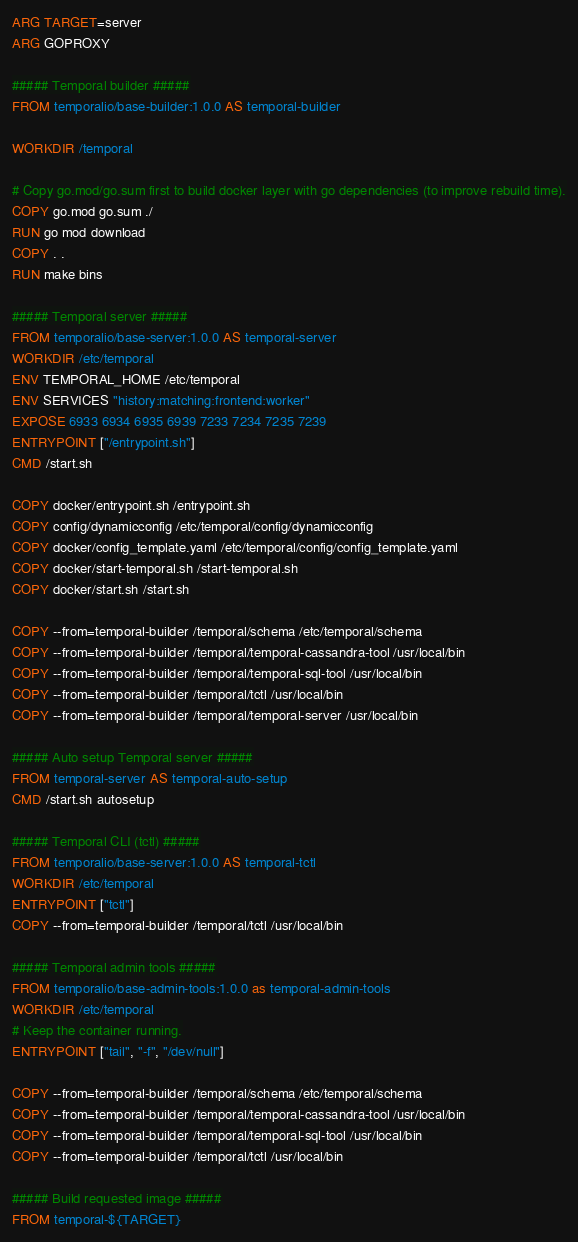<code> <loc_0><loc_0><loc_500><loc_500><_Dockerfile_>ARG TARGET=server
ARG GOPROXY

##### Temporal builder #####
FROM temporalio/base-builder:1.0.0 AS temporal-builder

WORKDIR /temporal

# Copy go.mod/go.sum first to build docker layer with go dependencies (to improve rebuild time).
COPY go.mod go.sum ./
RUN go mod download
COPY . .
RUN make bins

##### Temporal server #####
FROM temporalio/base-server:1.0.0 AS temporal-server
WORKDIR /etc/temporal
ENV TEMPORAL_HOME /etc/temporal
ENV SERVICES "history:matching:frontend:worker"
EXPOSE 6933 6934 6935 6939 7233 7234 7235 7239
ENTRYPOINT ["/entrypoint.sh"]
CMD /start.sh

COPY docker/entrypoint.sh /entrypoint.sh
COPY config/dynamicconfig /etc/temporal/config/dynamicconfig
COPY docker/config_template.yaml /etc/temporal/config/config_template.yaml
COPY docker/start-temporal.sh /start-temporal.sh
COPY docker/start.sh /start.sh

COPY --from=temporal-builder /temporal/schema /etc/temporal/schema
COPY --from=temporal-builder /temporal/temporal-cassandra-tool /usr/local/bin
COPY --from=temporal-builder /temporal/temporal-sql-tool /usr/local/bin
COPY --from=temporal-builder /temporal/tctl /usr/local/bin
COPY --from=temporal-builder /temporal/temporal-server /usr/local/bin

##### Auto setup Temporal server #####
FROM temporal-server AS temporal-auto-setup
CMD /start.sh autosetup

##### Temporal CLI (tctl) #####
FROM temporalio/base-server:1.0.0 AS temporal-tctl
WORKDIR /etc/temporal
ENTRYPOINT ["tctl"]
COPY --from=temporal-builder /temporal/tctl /usr/local/bin

##### Temporal admin tools #####
FROM temporalio/base-admin-tools:1.0.0 as temporal-admin-tools
WORKDIR /etc/temporal
# Keep the container running.
ENTRYPOINT ["tail", "-f", "/dev/null"]

COPY --from=temporal-builder /temporal/schema /etc/temporal/schema
COPY --from=temporal-builder /temporal/temporal-cassandra-tool /usr/local/bin
COPY --from=temporal-builder /temporal/temporal-sql-tool /usr/local/bin
COPY --from=temporal-builder /temporal/tctl /usr/local/bin

##### Build requested image #####
FROM temporal-${TARGET}
</code> 